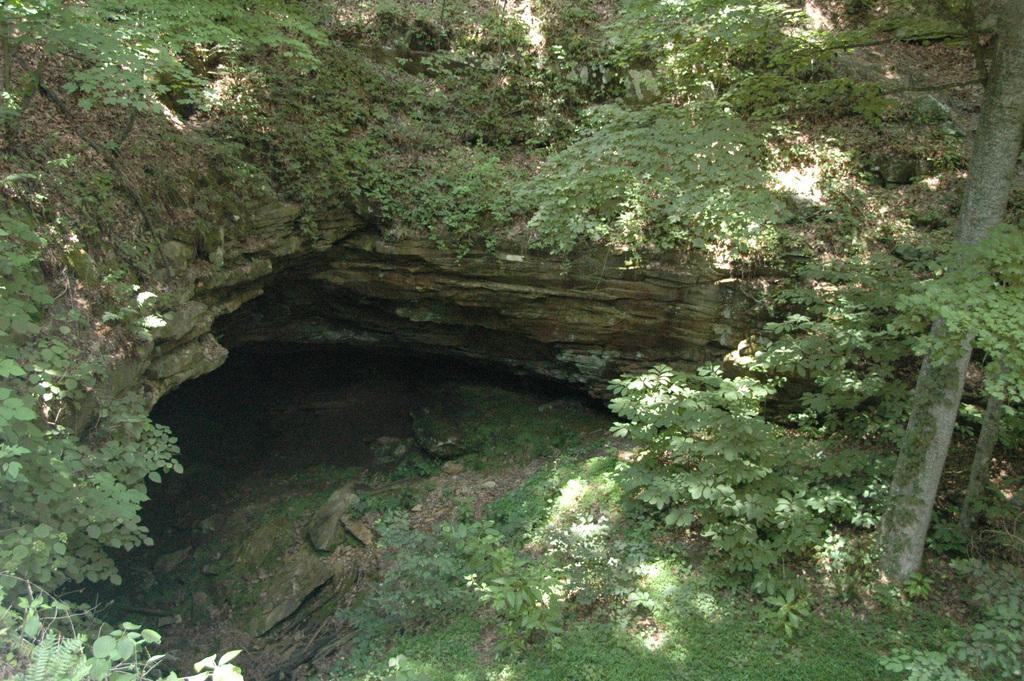What geological formation can be seen in the image? There is a cave in the image. What is located at the bottom of the image? Water, stones, and grass are present at the bottom of the image. Can you describe the stone pole in the image? There is a stone pole on the right side of the image. What type of hate can be seen in the image? There is no hate present in the image; it features a cave, water, stones, grass, and a stone pole. What is the chance of finding blood in the image? There is no blood present in the image. 